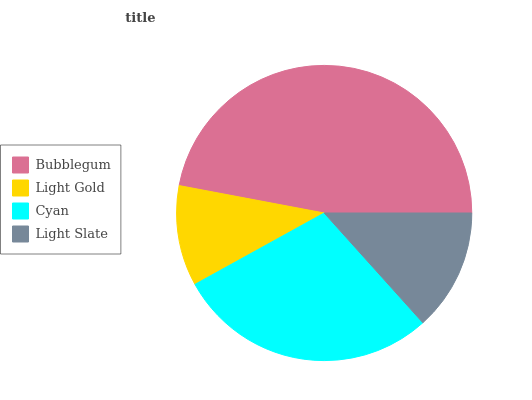Is Light Gold the minimum?
Answer yes or no. Yes. Is Bubblegum the maximum?
Answer yes or no. Yes. Is Cyan the minimum?
Answer yes or no. No. Is Cyan the maximum?
Answer yes or no. No. Is Cyan greater than Light Gold?
Answer yes or no. Yes. Is Light Gold less than Cyan?
Answer yes or no. Yes. Is Light Gold greater than Cyan?
Answer yes or no. No. Is Cyan less than Light Gold?
Answer yes or no. No. Is Cyan the high median?
Answer yes or no. Yes. Is Light Slate the low median?
Answer yes or no. Yes. Is Light Gold the high median?
Answer yes or no. No. Is Light Gold the low median?
Answer yes or no. No. 